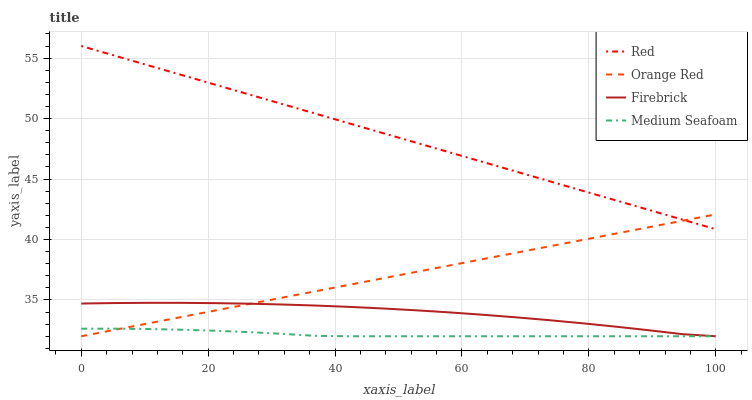Does Orange Red have the minimum area under the curve?
Answer yes or no. No. Does Orange Red have the maximum area under the curve?
Answer yes or no. No. Is Red the smoothest?
Answer yes or no. No. Is Red the roughest?
Answer yes or no. No. Does Red have the lowest value?
Answer yes or no. No. Does Orange Red have the highest value?
Answer yes or no. No. Is Firebrick less than Red?
Answer yes or no. Yes. Is Red greater than Firebrick?
Answer yes or no. Yes. Does Firebrick intersect Red?
Answer yes or no. No. 